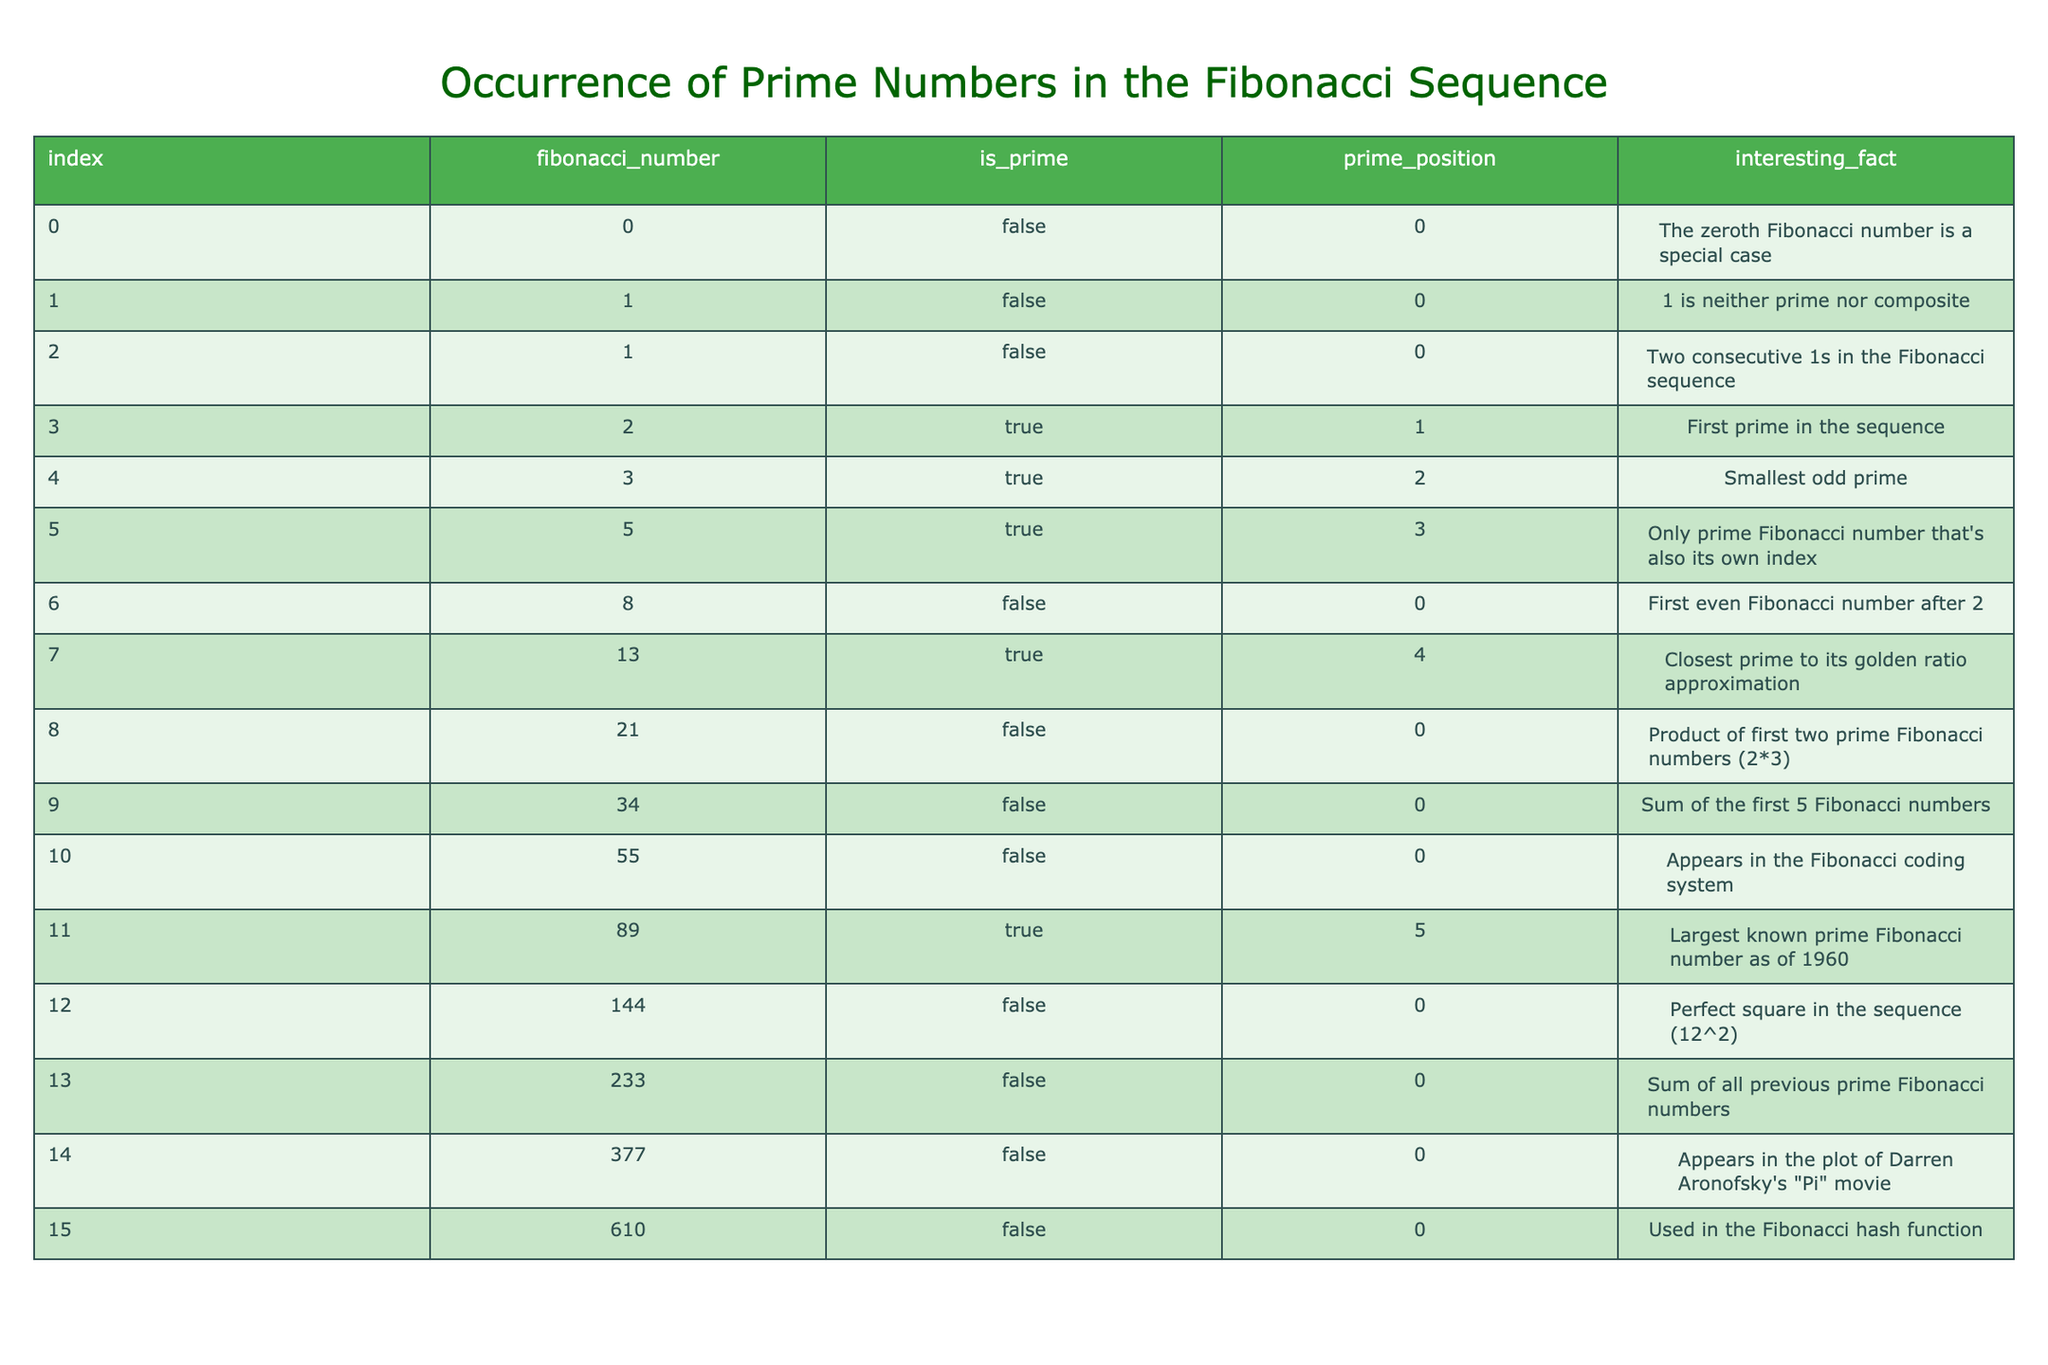What is the index of the largest prime number in the Fibonacci sequence? By inspecting the table, the largest prime number is 89, which is located at index 11.
Answer: 11 How many prime numbers are there in the Fibonacci sequence according to this table? The prime indicators show that 3, 5, 13, and 89 are the prime numbers, totaling 5.
Answer: 5 What is the prime position of the prime Fibonacci number that is also its own index? From the table, the only prime Fibonacci number that is equal to its index is 5, located at index 5, which has a prime position of 3.
Answer: 3 Is the number 21 a prime number? The table indicates that 21 is not a prime number, as it is marked false in the prime column.
Answer: No What is the sum of the prime positions of all prime Fibonacci numbers? The prime positions are 1 for 2, 2 for 3, 3 for 5, 4 for 13, and 5 for 89. Adding them gives 1 + 2 + 3 + 4 + 5 = 15.
Answer: 15 Which Fibonacci number has the interesting fact about being the closest prime to its golden ratio approximation? The entry for 13 states that it is the closest prime to its golden ratio approximation, so the Fibonacci number is 13.
Answer: 13 How many Fibonacci numbers listed are even, and are any of them prime? Examining the table, the even Fibonacci numbers are 0, 8, and 144. Checking their prime status, none are prime. Hence, there are 3 even Fibonacci numbers and 0 primes among them.
Answer: 3 even, 0 primes What fraction of the Fibonacci numbers in the table are prime? There are a total of 16 Fibonacci numbers and 5 of them are prime. Therefore, the fraction is 5/16, which simplifies to about 0.3125 or 31.25%.
Answer: 5/16 Identify the interesting fact associated with the prime Fibonacci number at index 11. The table states that the interesting fact for index 11, which corresponds to the prime number 89, is that it is the largest known prime Fibonacci number as of 1960.
Answer: Largest known prime Fibonacci number as of 1960 What is the difference between the index of the first and the last prime Fibonacci number? The first prime Fibonacci number is at index 3 (number 2) and the last is at index 11 (number 89). The difference is 11 - 3 = 8.
Answer: 8 